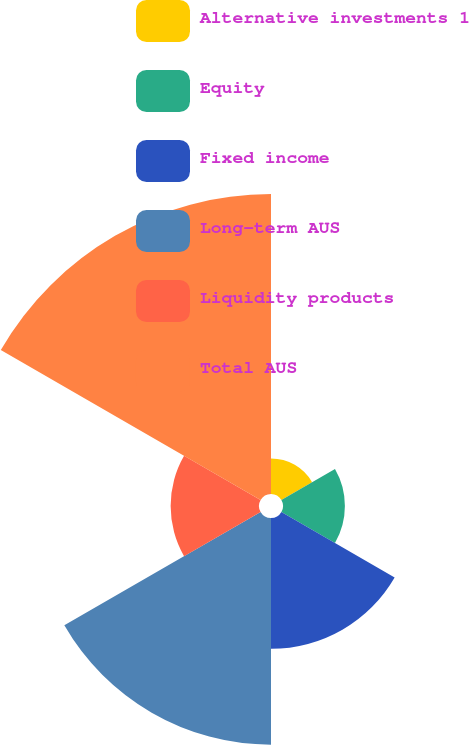Convert chart. <chart><loc_0><loc_0><loc_500><loc_500><pie_chart><fcel>Alternative investments 1<fcel>Equity<fcel>Fixed income<fcel>Long-term AUS<fcel>Liquidity products<fcel>Total AUS<nl><fcel>4.21%<fcel>7.34%<fcel>15.51%<fcel>26.88%<fcel>10.48%<fcel>35.58%<nl></chart> 